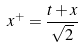<formula> <loc_0><loc_0><loc_500><loc_500>x ^ { + } = \frac { t + x } { \sqrt { 2 } }</formula> 